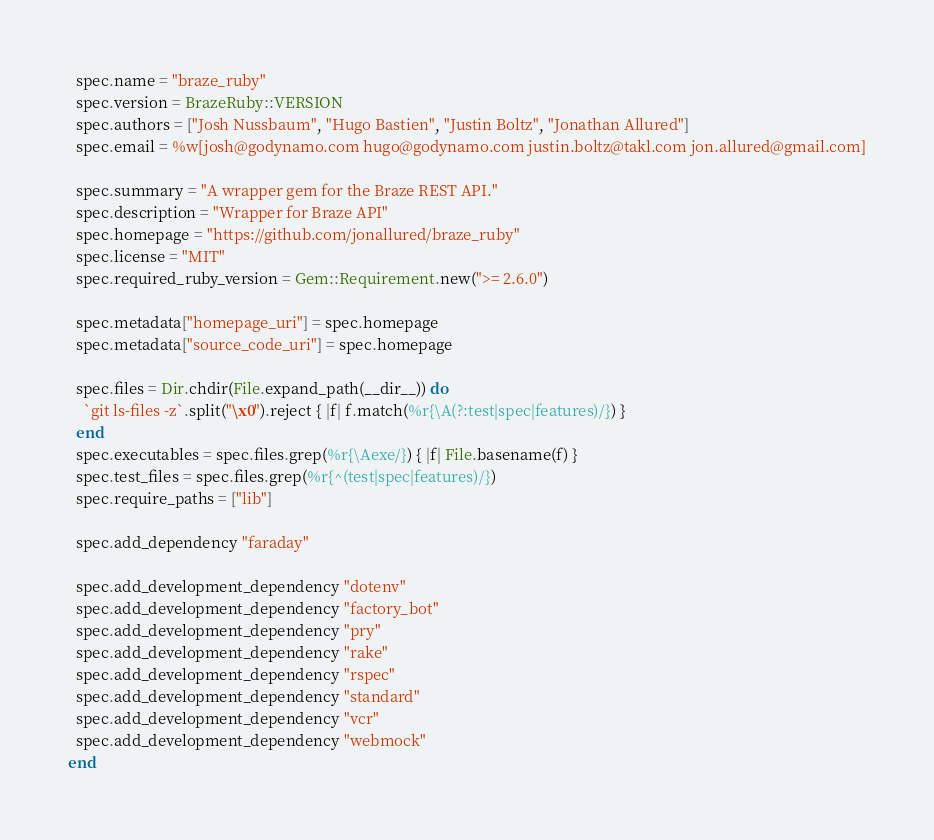Convert code to text. <code><loc_0><loc_0><loc_500><loc_500><_Ruby_>  spec.name = "braze_ruby"
  spec.version = BrazeRuby::VERSION
  spec.authors = ["Josh Nussbaum", "Hugo Bastien", "Justin Boltz", "Jonathan Allured"]
  spec.email = %w[josh@godynamo.com hugo@godynamo.com justin.boltz@takl.com jon.allured@gmail.com]

  spec.summary = "A wrapper gem for the Braze REST API."
  spec.description = "Wrapper for Braze API"
  spec.homepage = "https://github.com/jonallured/braze_ruby"
  spec.license = "MIT"
  spec.required_ruby_version = Gem::Requirement.new(">= 2.6.0")

  spec.metadata["homepage_uri"] = spec.homepage
  spec.metadata["source_code_uri"] = spec.homepage

  spec.files = Dir.chdir(File.expand_path(__dir__)) do
    `git ls-files -z`.split("\x0").reject { |f| f.match(%r{\A(?:test|spec|features)/}) }
  end
  spec.executables = spec.files.grep(%r{\Aexe/}) { |f| File.basename(f) }
  spec.test_files = spec.files.grep(%r{^(test|spec|features)/})
  spec.require_paths = ["lib"]

  spec.add_dependency "faraday"

  spec.add_development_dependency "dotenv"
  spec.add_development_dependency "factory_bot"
  spec.add_development_dependency "pry"
  spec.add_development_dependency "rake"
  spec.add_development_dependency "rspec"
  spec.add_development_dependency "standard"
  spec.add_development_dependency "vcr"
  spec.add_development_dependency "webmock"
end
</code> 